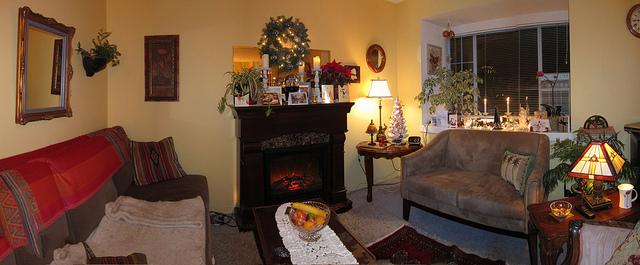Are all lamps on?
Keep it brief. Yes. What holiday was the picture taken during?
Quick response, please. Christmas. Is the room crowded with people?
Give a very brief answer. No. 